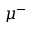<formula> <loc_0><loc_0><loc_500><loc_500>\mu ^ { - }</formula> 